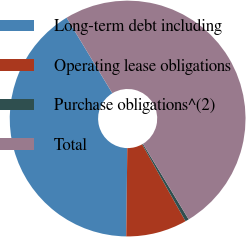Convert chart. <chart><loc_0><loc_0><loc_500><loc_500><pie_chart><fcel>Long-term debt including<fcel>Operating lease obligations<fcel>Purchase obligations^(2)<fcel>Total<nl><fcel>41.15%<fcel>8.36%<fcel>0.49%<fcel>50.0%<nl></chart> 